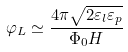<formula> <loc_0><loc_0><loc_500><loc_500>\varphi _ { L } \simeq \frac { 4 \pi \sqrt { 2 \varepsilon _ { l } \varepsilon _ { p } } } { \Phi _ { 0 } H }</formula> 